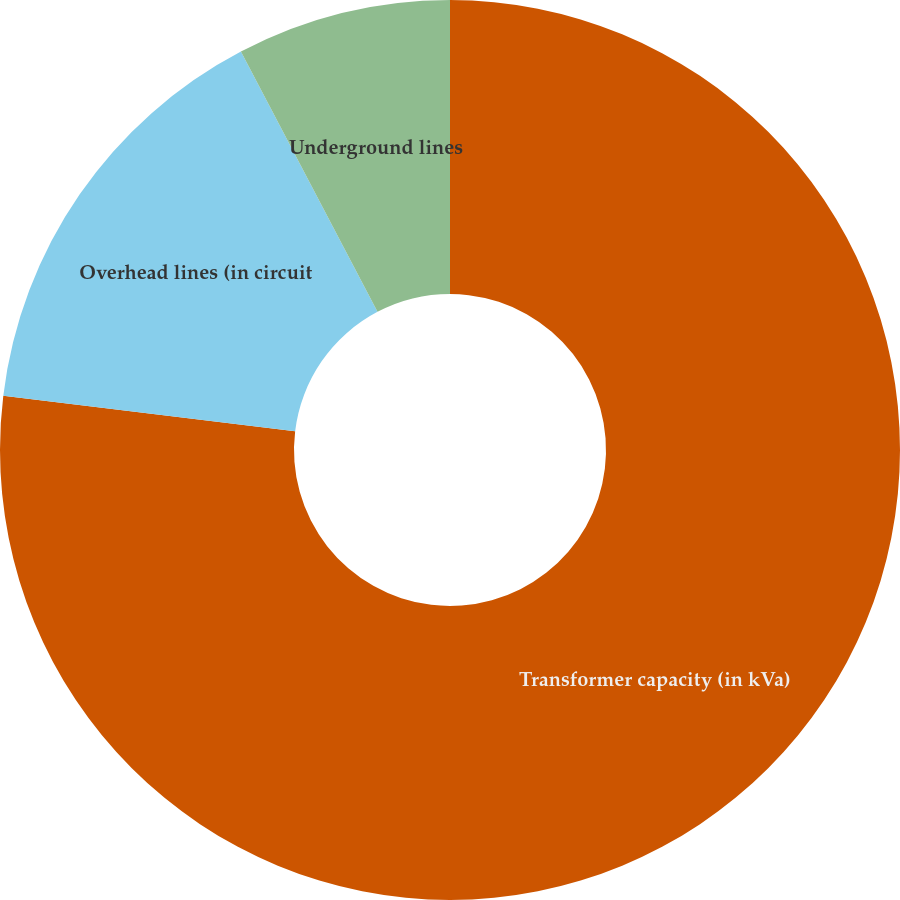Convert chart to OTSL. <chart><loc_0><loc_0><loc_500><loc_500><pie_chart><fcel>Number of substations owned<fcel>Transformer capacity (in kVa)<fcel>Overhead lines (in circuit<fcel>Underground lines<nl><fcel>0.0%<fcel>76.92%<fcel>15.38%<fcel>7.69%<nl></chart> 